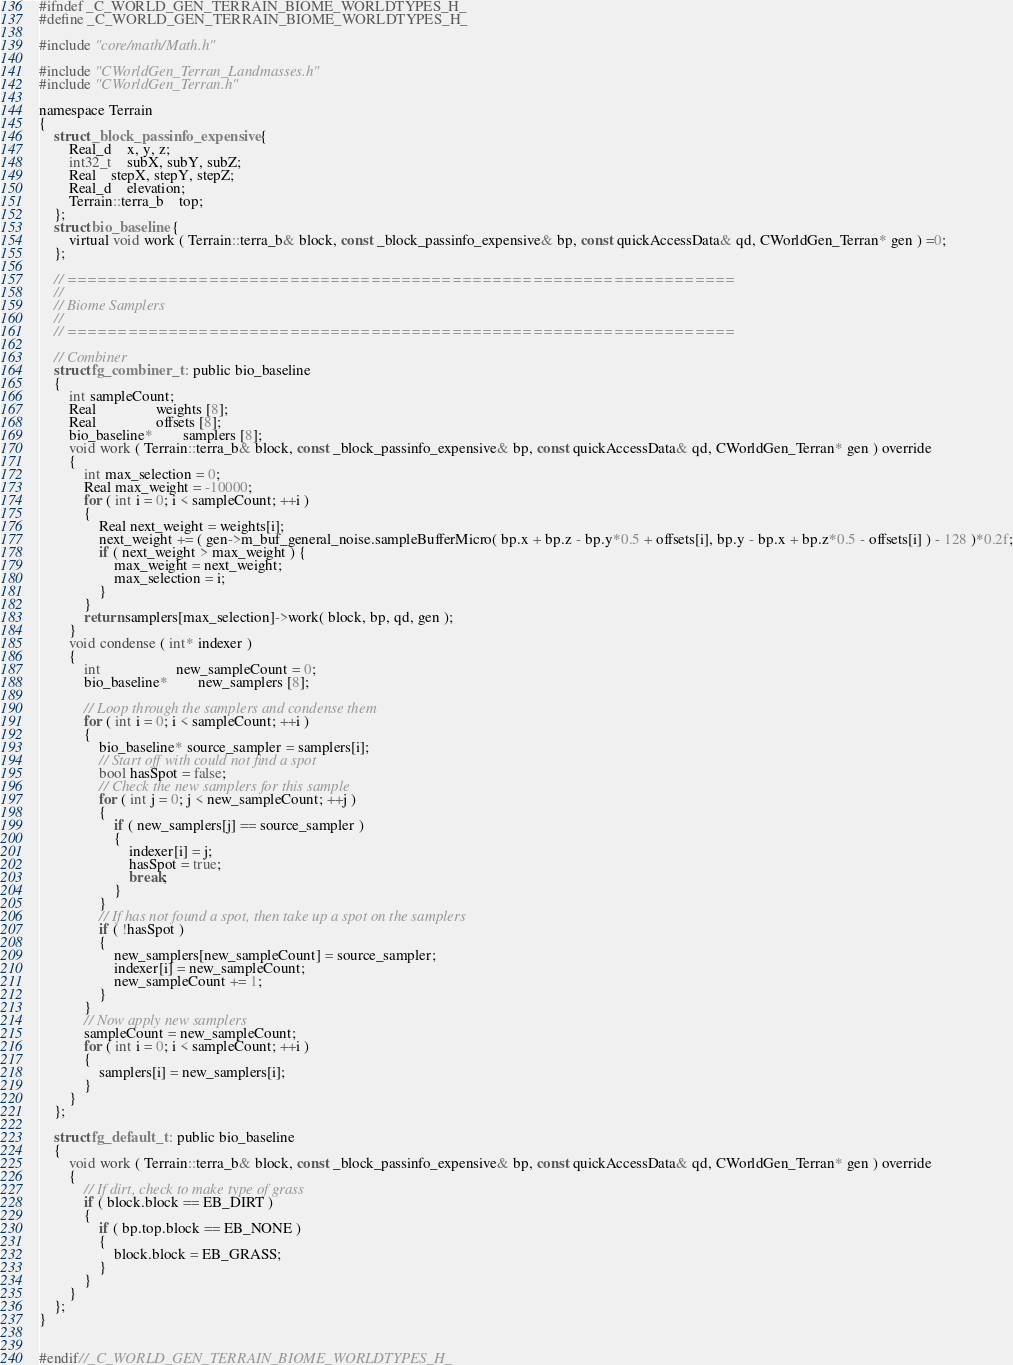Convert code to text. <code><loc_0><loc_0><loc_500><loc_500><_C_>
#ifndef _C_WORLD_GEN_TERRAIN_BIOME_WORLDTYPES_H_
#define _C_WORLD_GEN_TERRAIN_BIOME_WORLDTYPES_H_

#include "core/math/Math.h"

#include "CWorldGen_Terran_Landmasses.h"
#include "CWorldGen_Terran.h"

namespace Terrain
{
	struct _block_passinfo_expensive {
		Real_d	x, y, z;
		int32_t	subX, subY, subZ;
		Real	stepX, stepY, stepZ;
		Real_d	elevation;
		Terrain::terra_b	top;
	};
	struct bio_baseline {
		virtual void work ( Terrain::terra_b& block, const _block_passinfo_expensive& bp, const quickAccessData& qd, CWorldGen_Terran* gen ) =0; 
	};

	// ==================================================================
	//
	// Biome Samplers
	//
	// ==================================================================

	// Combiner
	struct fg_combiner_t : public bio_baseline
	{
		int sampleCount;
		Real				weights [8];
		Real				offsets [8];
		bio_baseline*		samplers [8];
		void work ( Terrain::terra_b& block, const _block_passinfo_expensive& bp, const quickAccessData& qd, CWorldGen_Terran* gen ) override
		{
			int max_selection = 0;
			Real max_weight = -10000;
			for ( int i = 0; i < sampleCount; ++i )
			{
				Real next_weight = weights[i];
				next_weight += ( gen->m_buf_general_noise.sampleBufferMicro( bp.x + bp.z - bp.y*0.5 + offsets[i], bp.y - bp.x + bp.z*0.5 - offsets[i] ) - 128 )*0.2f;
				if ( next_weight > max_weight ) {
					max_weight = next_weight;
					max_selection = i;
				}
			}
			return samplers[max_selection]->work( block, bp, qd, gen );
		}
		void condense ( int* indexer )
		{
			int					new_sampleCount = 0;
			bio_baseline*		new_samplers [8];

			// Loop through the samplers and condense them
			for ( int i = 0; i < sampleCount; ++i )
			{
				bio_baseline* source_sampler = samplers[i];
				// Start off with could not find a spot
				bool hasSpot = false;
				// Check the new samplers for this sample
				for ( int j = 0; j < new_sampleCount; ++j )
				{
					if ( new_samplers[j] == source_sampler )
					{
						indexer[i] = j;
						hasSpot = true;
						break;
					}
				}
				// If has not found a spot, then take up a spot on the samplers
				if ( !hasSpot )
				{
					new_samplers[new_sampleCount] = source_sampler;
					indexer[i] = new_sampleCount;
					new_sampleCount += 1;
				}
			}
			// Now apply new samplers
			sampleCount = new_sampleCount;
			for ( int i = 0; i < sampleCount; ++i )
			{
				samplers[i] = new_samplers[i];
			}
		}
	};

	struct fg_default_t : public bio_baseline
	{
		void work ( Terrain::terra_b& block, const _block_passinfo_expensive& bp, const quickAccessData& qd, CWorldGen_Terran* gen ) override
		{
			// If dirt, check to make type of grass
			if ( block.block == EB_DIRT )
			{
				if ( bp.top.block == EB_NONE )
				{
					block.block = EB_GRASS;
				}
			}
		}
	};
}


#endif//_C_WORLD_GEN_TERRAIN_BIOME_WORLDTYPES_H_</code> 